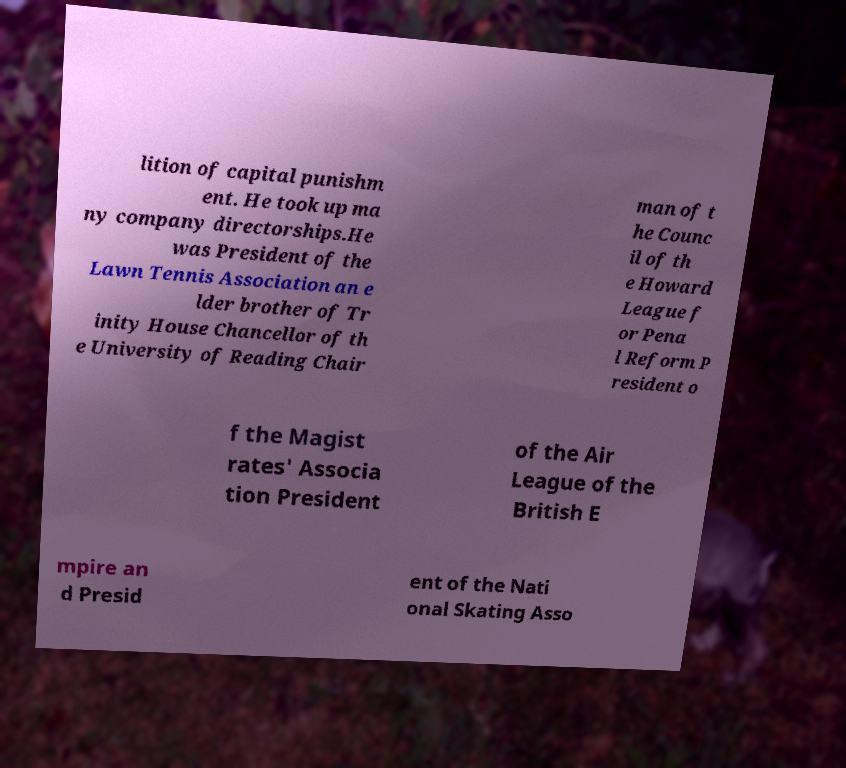Could you assist in decoding the text presented in this image and type it out clearly? lition of capital punishm ent. He took up ma ny company directorships.He was President of the Lawn Tennis Association an e lder brother of Tr inity House Chancellor of th e University of Reading Chair man of t he Counc il of th e Howard League f or Pena l Reform P resident o f the Magist rates' Associa tion President of the Air League of the British E mpire an d Presid ent of the Nati onal Skating Asso 